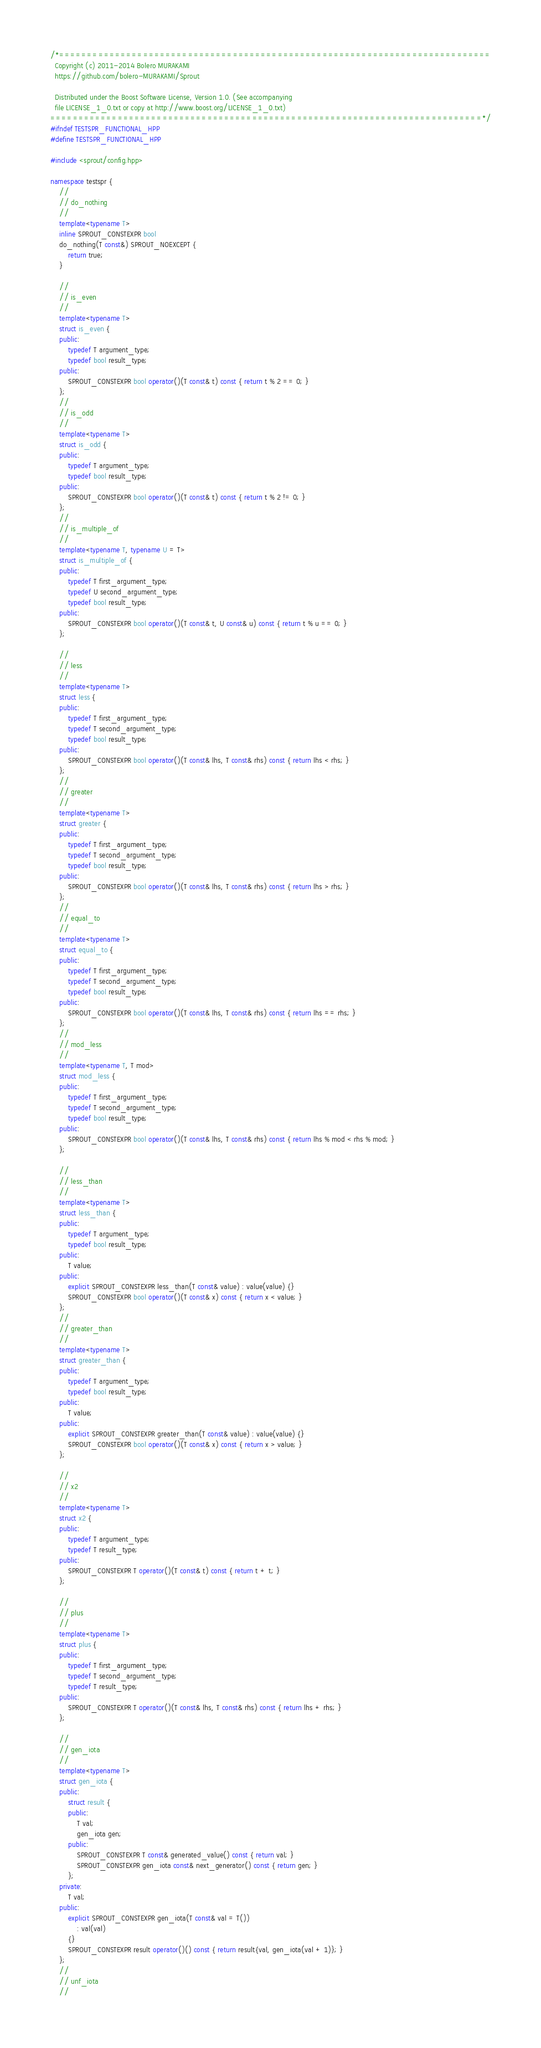Convert code to text. <code><loc_0><loc_0><loc_500><loc_500><_C++_>/*=============================================================================
  Copyright (c) 2011-2014 Bolero MURAKAMI
  https://github.com/bolero-MURAKAMI/Sprout

  Distributed under the Boost Software License, Version 1.0. (See accompanying
  file LICENSE_1_0.txt or copy at http://www.boost.org/LICENSE_1_0.txt)
=============================================================================*/
#ifndef TESTSPR_FUNCTIONAL_HPP
#define TESTSPR_FUNCTIONAL_HPP

#include <sprout/config.hpp>

namespace testspr {
	//
	// do_nothing
	//
	template<typename T>
	inline SPROUT_CONSTEXPR bool
	do_nothing(T const&) SPROUT_NOEXCEPT {
		return true;
	}

	//
	// is_even
	//
	template<typename T>
	struct is_even {
	public:
		typedef T argument_type;
		typedef bool result_type;
	public:
		SPROUT_CONSTEXPR bool operator()(T const& t) const { return t % 2 == 0; }
	};
	//
	// is_odd
	//
	template<typename T>
	struct is_odd {
	public:
		typedef T argument_type;
		typedef bool result_type;
	public:
		SPROUT_CONSTEXPR bool operator()(T const& t) const { return t % 2 != 0; }
	};
	//
	// is_multiple_of
	//
	template<typename T, typename U = T>
	struct is_multiple_of {
	public:
		typedef T first_argument_type;
		typedef U second_argument_type;
		typedef bool result_type;
	public:
		SPROUT_CONSTEXPR bool operator()(T const& t, U const& u) const { return t % u == 0; }
	};

	//
	// less
	//
	template<typename T>
	struct less {
	public:
		typedef T first_argument_type;
		typedef T second_argument_type;
		typedef bool result_type;
	public:
		SPROUT_CONSTEXPR bool operator()(T const& lhs, T const& rhs) const { return lhs < rhs; }
	};
	//
	// greater
	//
	template<typename T>
	struct greater {
	public:
		typedef T first_argument_type;
		typedef T second_argument_type;
		typedef bool result_type;
	public:
		SPROUT_CONSTEXPR bool operator()(T const& lhs, T const& rhs) const { return lhs > rhs; }
	};
	//
	// equal_to
	//
	template<typename T>
	struct equal_to {
	public:
		typedef T first_argument_type;
		typedef T second_argument_type;
		typedef bool result_type;
	public:
		SPROUT_CONSTEXPR bool operator()(T const& lhs, T const& rhs) const { return lhs == rhs; }
	};
	//
	// mod_less
	//
	template<typename T, T mod>
	struct mod_less {
	public:
		typedef T first_argument_type;
		typedef T second_argument_type;
		typedef bool result_type;
	public:
		SPROUT_CONSTEXPR bool operator()(T const& lhs, T const& rhs) const { return lhs % mod < rhs % mod; }
	};

	//
	// less_than
	//
	template<typename T>
	struct less_than {
	public:
		typedef T argument_type;
		typedef bool result_type;
	public:
		T value;
	public:
		explicit SPROUT_CONSTEXPR less_than(T const& value) : value(value) {}
		SPROUT_CONSTEXPR bool operator()(T const& x) const { return x < value; }
	};
	//
	// greater_than
	//
	template<typename T>
	struct greater_than {
	public:
		typedef T argument_type;
		typedef bool result_type;
	public:
		T value;
	public:
		explicit SPROUT_CONSTEXPR greater_than(T const& value) : value(value) {}
		SPROUT_CONSTEXPR bool operator()(T const& x) const { return x > value; }
	};

	//
	// x2
	//
	template<typename T>
	struct x2 {
	public:
		typedef T argument_type;
		typedef T result_type;
	public:
		SPROUT_CONSTEXPR T operator()(T const& t) const { return t + t; }
	};

	//
	// plus
	//
	template<typename T>
	struct plus {
	public:
		typedef T first_argument_type;
		typedef T second_argument_type;
		typedef T result_type;
	public:
		SPROUT_CONSTEXPR T operator()(T const& lhs, T const& rhs) const { return lhs + rhs; }
	};

	//
	// gen_iota
	//
	template<typename T>
	struct gen_iota {
	public:
		struct result {
		public:
			T val;
			gen_iota gen;
		public:
			SPROUT_CONSTEXPR T const& generated_value() const { return val; }
			SPROUT_CONSTEXPR gen_iota const& next_generator() const { return gen; }
		};
	private:
		T val;
	public:
		explicit SPROUT_CONSTEXPR gen_iota(T const& val = T())
			: val(val)
		{}
		SPROUT_CONSTEXPR result operator()() const { return result{val, gen_iota(val + 1)}; }
	};
	//
	// unf_iota
	//</code> 